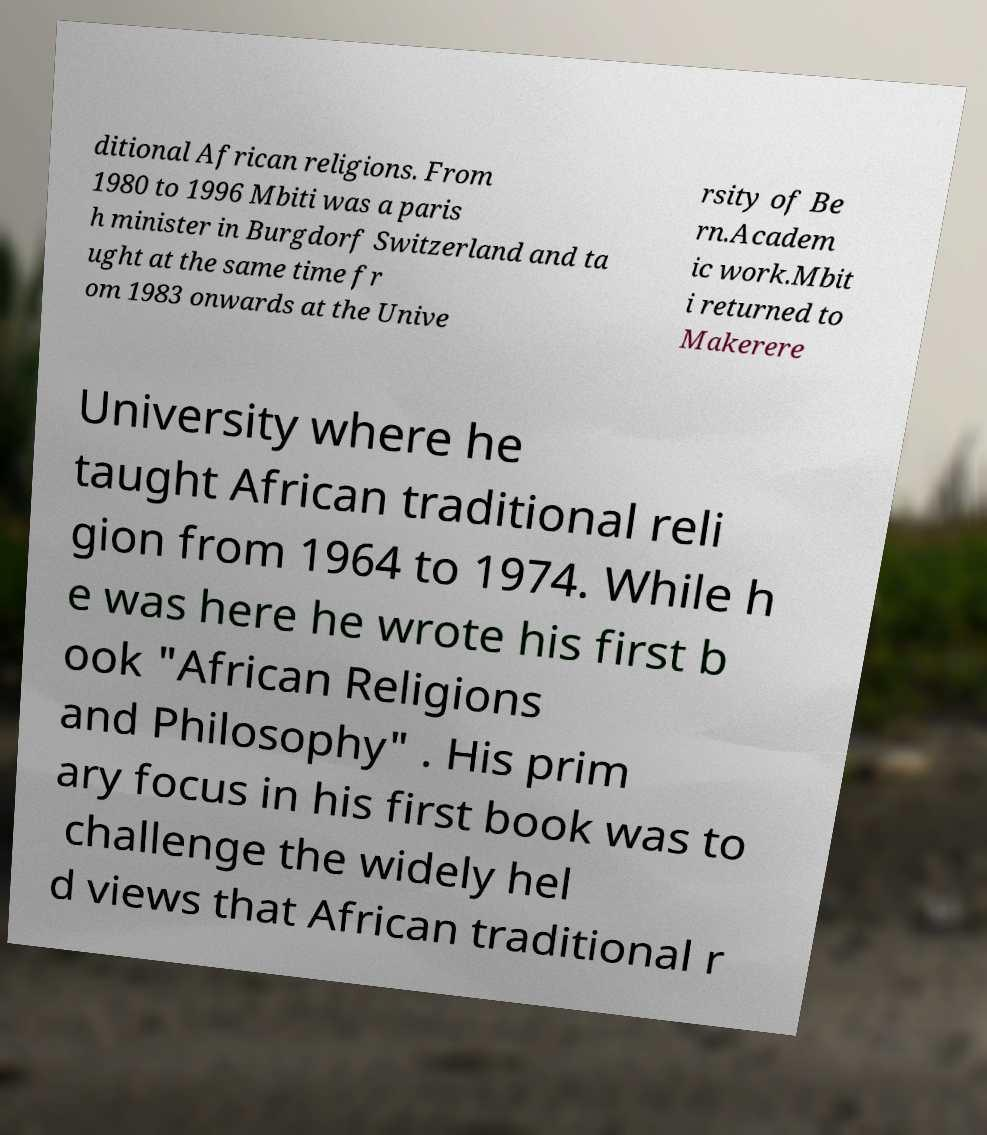Could you extract and type out the text from this image? ditional African religions. From 1980 to 1996 Mbiti was a paris h minister in Burgdorf Switzerland and ta ught at the same time fr om 1983 onwards at the Unive rsity of Be rn.Academ ic work.Mbit i returned to Makerere University where he taught African traditional reli gion from 1964 to 1974. While h e was here he wrote his first b ook "African Religions and Philosophy" . His prim ary focus in his first book was to challenge the widely hel d views that African traditional r 